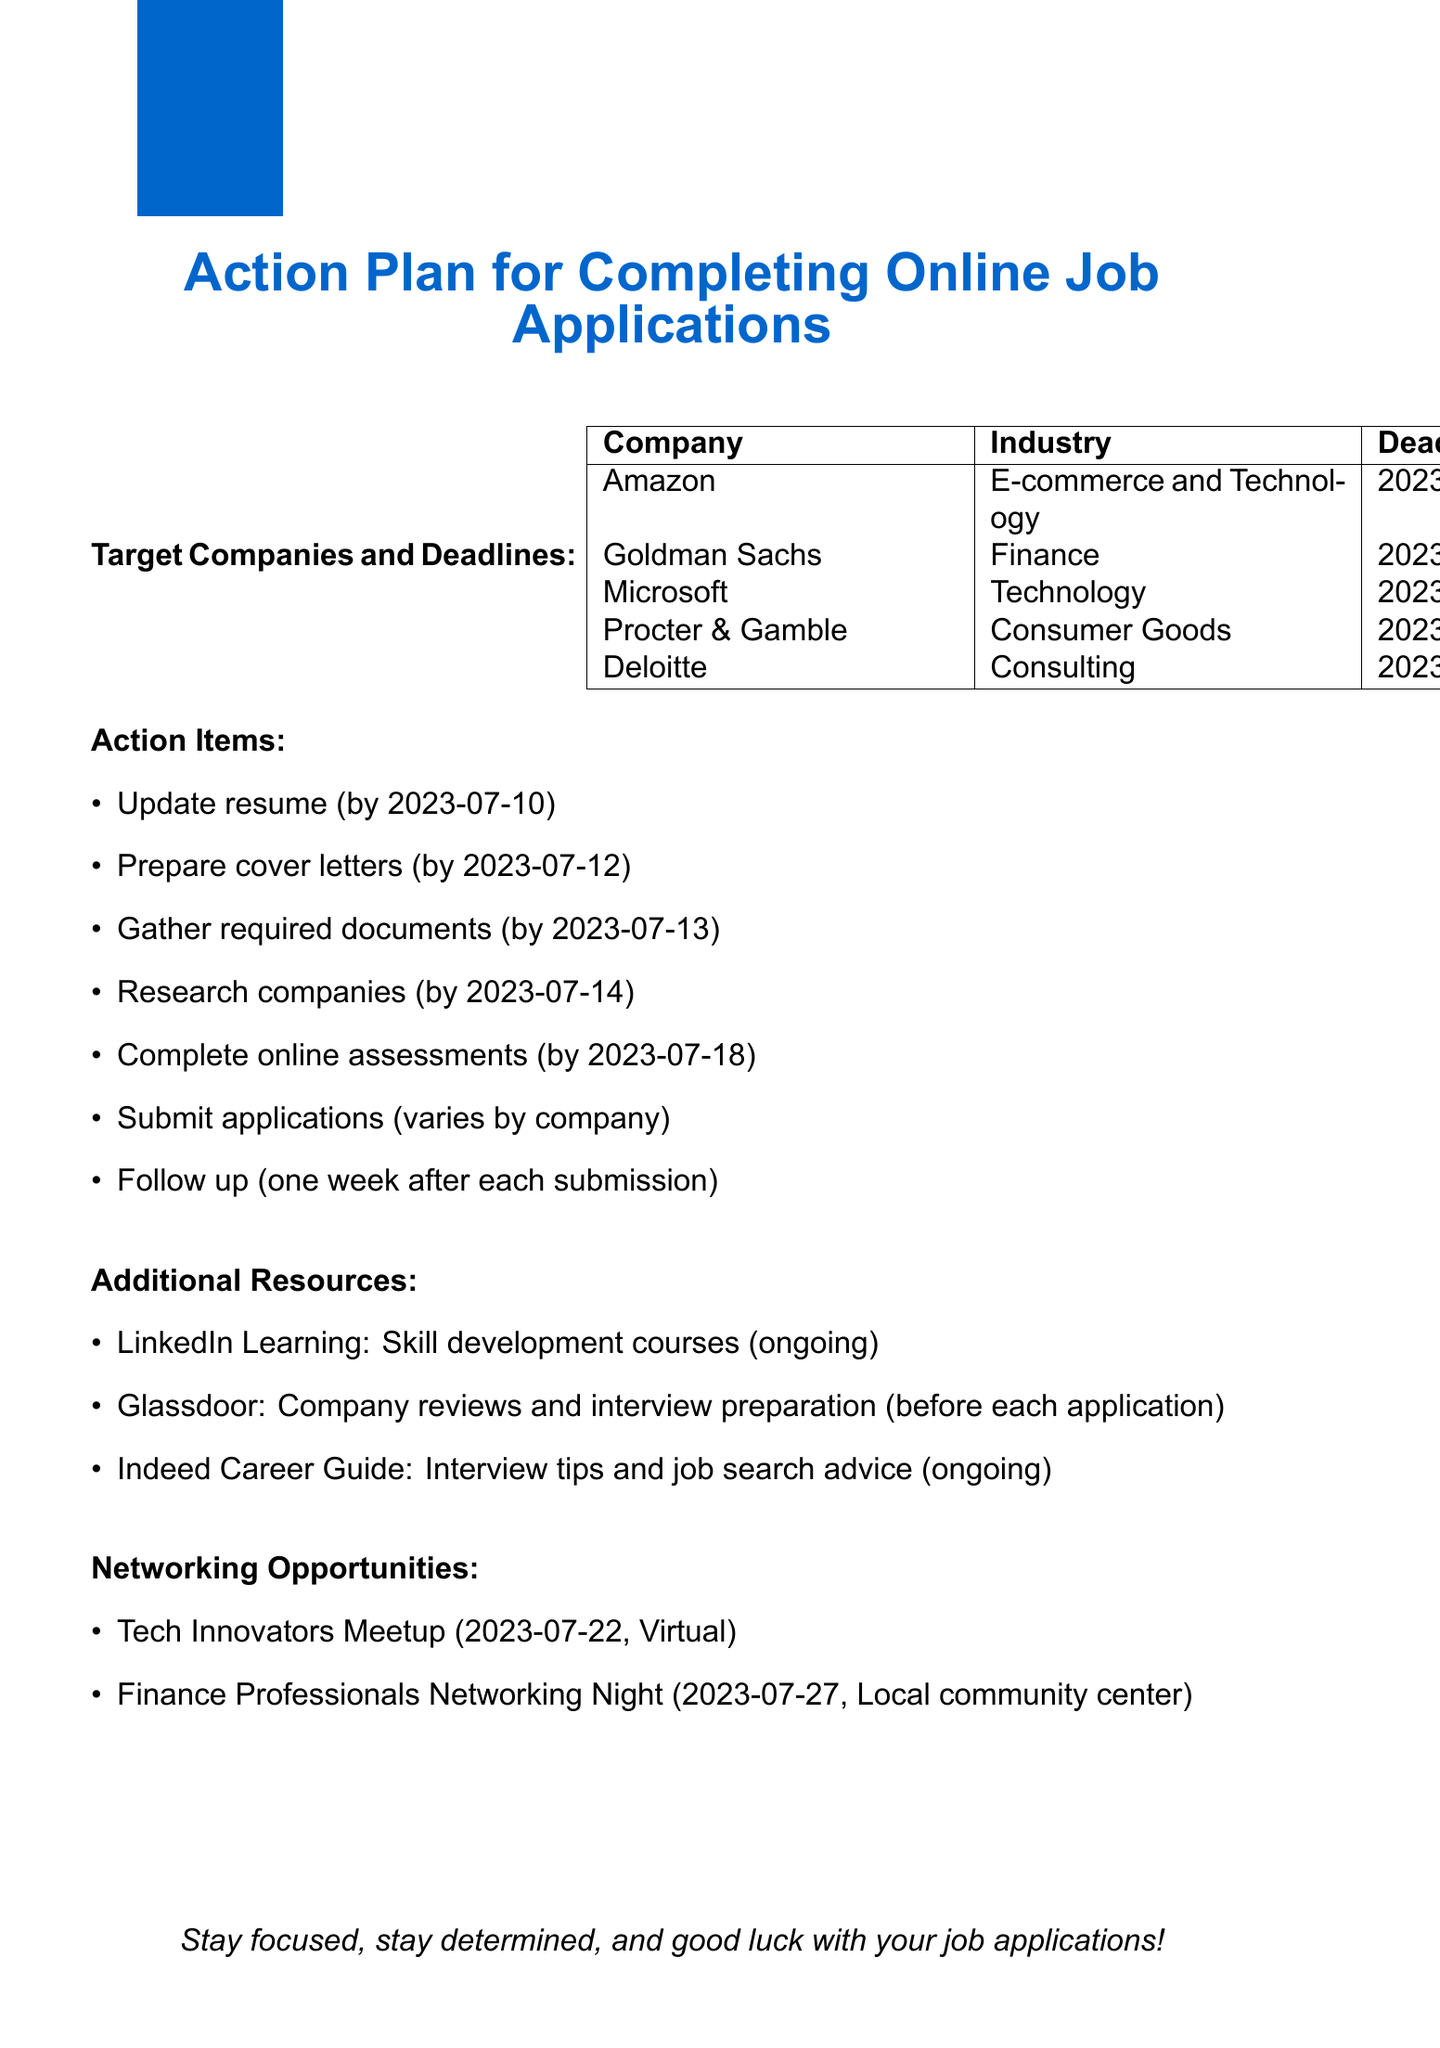What is the application deadline for Amazon? The application deadline for Amazon is listed in the document under Target Companies and Deadlines.
Answer: 2023-07-15 What is the industry of Goldman Sachs? The industry of Goldman Sachs is mentioned in the document under Target Companies and Deadlines.
Answer: Finance What task must be completed by July 10? The task due by July 10 is indicated in the Action Items section of the document.
Answer: Update resume What is the deadline to complete online assessments? The deadline for completing online assessments is specified in the Action Items section of the document.
Answer: 2023-07-18 Which event is relevant for the Microsoft application? The event listed in the Networking Opportunities section relevant for Microsoft applications can be found in the document.
Answer: Tech Innovators Meetup What is the purpose of Glassdoor according to the document? The purpose of Glassdoor is outlined in the Additional Resources section, providing specific insights.
Answer: Company reviews and interview preparation How many target companies are listed in the document? The total number of companies is derived from the Target Companies section where they are enumerated.
Answer: Five When should follow-up emails be sent? The timeframe for follow-up emails is specified in the Action Items section of the document.
Answer: One week after each submission Which task requires gathering transcripts? The task related to gathering transcripts is mentioned directly in the Action Items section of the document.
Answer: Gather required documents 